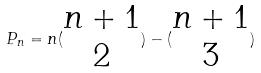Convert formula to latex. <formula><loc_0><loc_0><loc_500><loc_500>P _ { n } = n ( \begin{matrix} n + 1 \\ 2 \end{matrix} ) - ( \begin{matrix} n + 1 \\ 3 \end{matrix} )</formula> 